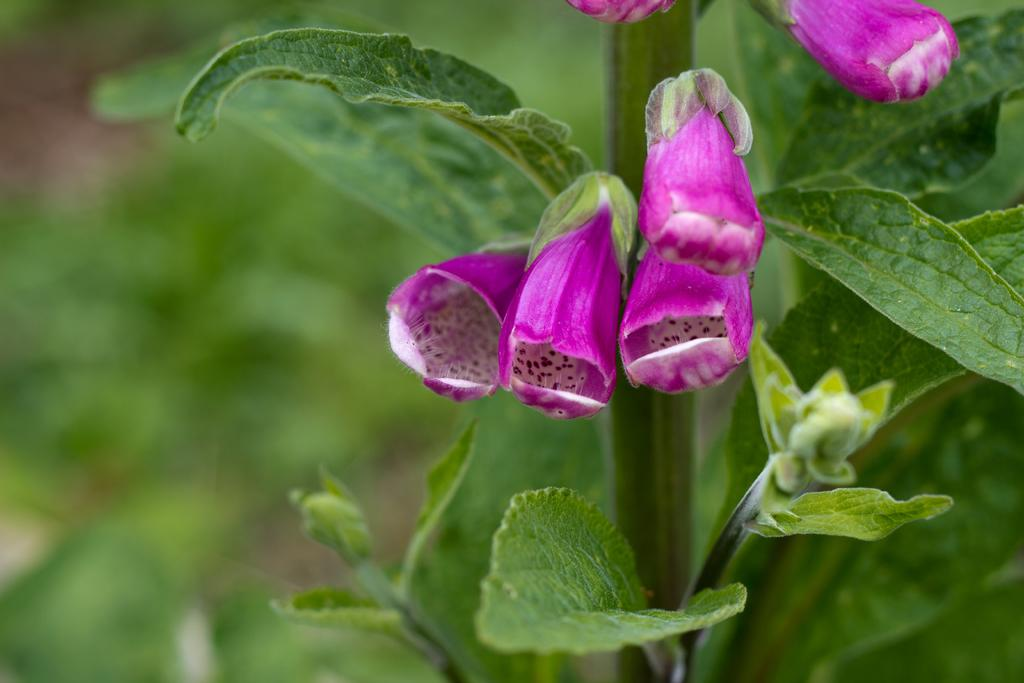What type of plant is visible in the image? There is a plant in the image, and it has flowers, buds, and leaves. What stage of growth are the flowers in the image? The flowers are visible in the image, but it is not clear what stage of growth they are in. What other parts of the plant can be seen in the image? The plant has buds and leaves in addition to the flowers. How would you describe the background of the image? The background of the image is blurry. Where is your aunt sitting in the image? There is no mention of an aunt or any person in the image; it only features a plant. How many ducks are visible in the image? There are no ducks present in the image; it only features a plant. 